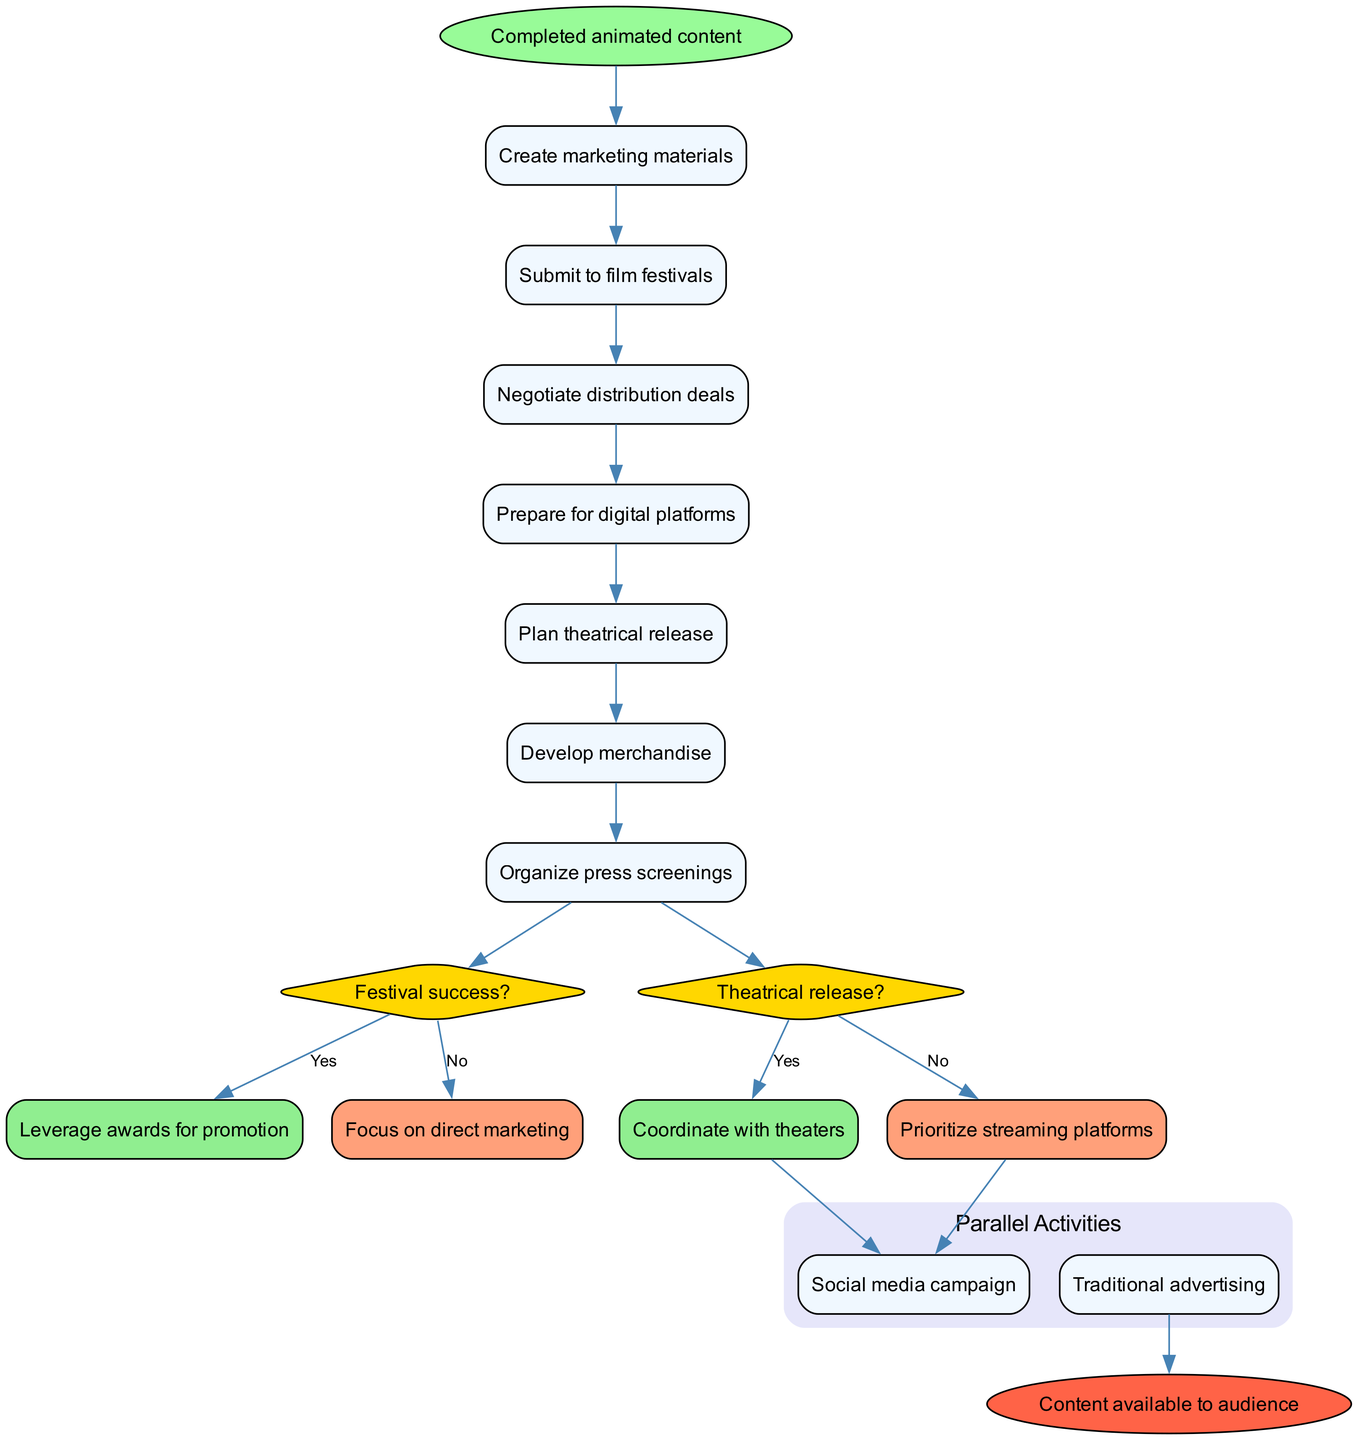What is the starting point of the process? The process begins with "Completed animated content," which is indicated as the first node in the diagram.
Answer: Completed animated content How many activities are listed in the diagram? There are seven activities shown in the diagram, each represented as a rectangular node.
Answer: 7 What is the decision point related to film festivals? The decision point in question is "Festival success?" which is indicated in a diamond-shaped node connected to the end of the activities.
Answer: Festival success? What do you do if the theatrical release is a "No"? If the answer to the theatrical release question is "No," the diagram specifies to "Prioritize streaming platforms" as the next step.
Answer: Prioritize streaming platforms What parallel activities are involved in the marketing process? The diagram identifies two parallel activities: "Social media campaign" and "Traditional advertising," which are grouped together in a subgraph.
Answer: Social media campaign and Traditional advertising What happens if there is festival success? If there is festival success, the flow indicates to "Leverage awards for promotion" as the subsequent action taken.
Answer: Leverage awards for promotion How many edges connect to the end node? The end node "Content available to audience" is reached by a single edge from the last parallel activity, indicating that it is the final step in the process.
Answer: 1 What is the last activity performed before the decisions? The last activity performed before reaching any decision is "Organize press screenings," shown in the order of activities.
Answer: Organize press screenings If the last decision is "Yes," what is the next action? If the last decision about theatrical release is "Yes," the process requires to "Coordinate with theaters,” as shown in the flow of the diagram.
Answer: Coordinate with theaters 